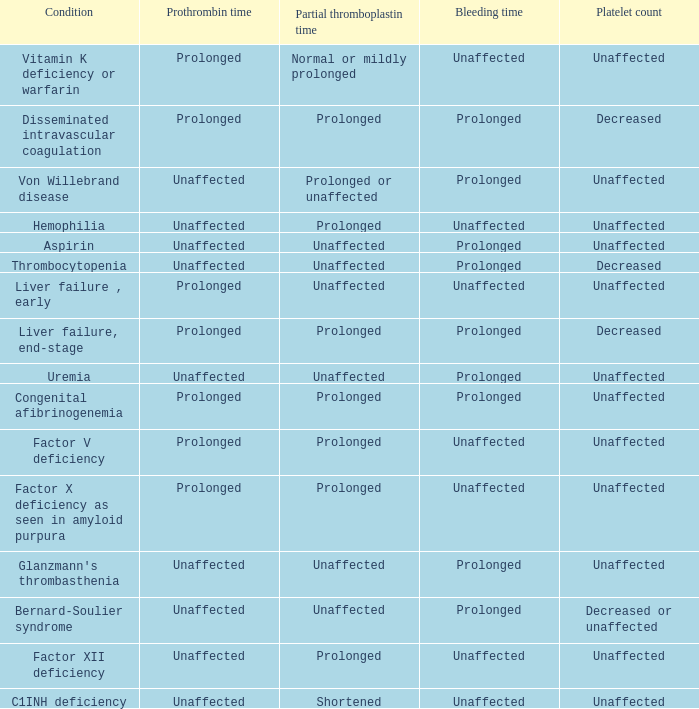Which type of bleeding is associated with the congenital afibrinogenemia condition? Prolonged. 